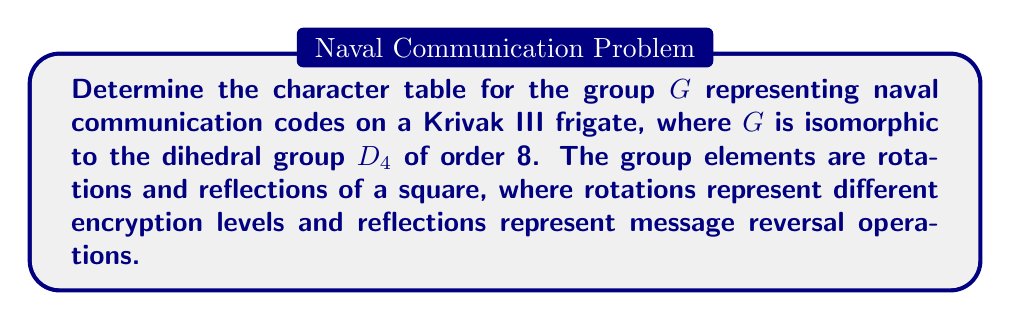What is the answer to this math problem? 1. First, identify the conjugacy classes of $D_4$:
   - $\{e\}$ (identity)
   - $\{r^2\}$ (180° rotation)
   - $\{r, r^3\}$ (90° and 270° rotations)
   - $\{s, sr^2\}$ (reflections across diagonals)
   - $\{sr, sr^3\}$ (reflections across vertical and horizontal axes)

2. Determine the number of irreducible representations:
   - Number of irreducible representations = Number of conjugacy classes = 5

3. Calculate the dimensions of irreducible representations:
   $\sum_{i=1}^5 d_i^2 = |G| = 8$, where $d_i$ are the dimensions.
   The only solution is $1^2 + 1^2 + 1^2 + 1^2 + 2^2 = 8$

4. Construct the character table:
   - Four 1-dimensional representations: $\chi_1, \chi_2, \chi_3, \chi_4$
   - One 2-dimensional representation: $\chi_5$

5. Fill in the trivial representation $\chi_1$ (all 1's)

6. For $\chi_2$, assign -1 to rotations and 1 to reflections:
   $\chi_2(r) = \chi_2(r^3) = -1$, $\chi_2(s) = \chi_2(sr) = \chi_2(sr^2) = \chi_2(sr^3) = 1$

7. For $\chi_3$, assign 1 to rotations and reflections across diagonals, -1 to others:
   $\chi_3(r) = \chi_3(r^3) = 1$, $\chi_3(s) = \chi_3(sr^2) = 1$, $\chi_3(sr) = \chi_3(sr^3) = -1$

8. For $\chi_4$, assign 1 to rotations and reflections across axes, -1 to others:
   $\chi_4(r) = \chi_4(r^3) = 1$, $\chi_4(s) = \chi_4(sr^2) = -1$, $\chi_4(sr) = \chi_4(sr^3) = 1$

9. For $\chi_5$ (2-dimensional), use the trace of the corresponding matrices:
   $\chi_5(e) = 2$, $\chi_5(r^2) = -2$, $\chi_5(r) = \chi_5(r^3) = 0$,
   $\chi_5(s) = \chi_5(sr^2) = 0$, $\chi_5(sr) = \chi_5(sr^3) = 0$

10. Verify orthogonality relations to ensure the character table is correct.
Answer: $$
\begin{array}{c|ccccc}
D_4 & \{e\} & \{r^2\} & \{r,r^3\} & \{s,sr^2\} & \{sr,sr^3\} \\
\hline
\chi_1 & 1 & 1 & 1 & 1 & 1 \\
\chi_2 & 1 & 1 & -1 & 1 & 1 \\
\chi_3 & 1 & 1 & 1 & 1 & -1 \\
\chi_4 & 1 & 1 & 1 & -1 & 1 \\
\chi_5 & 2 & -2 & 0 & 0 & 0
\end{array}
$$ 